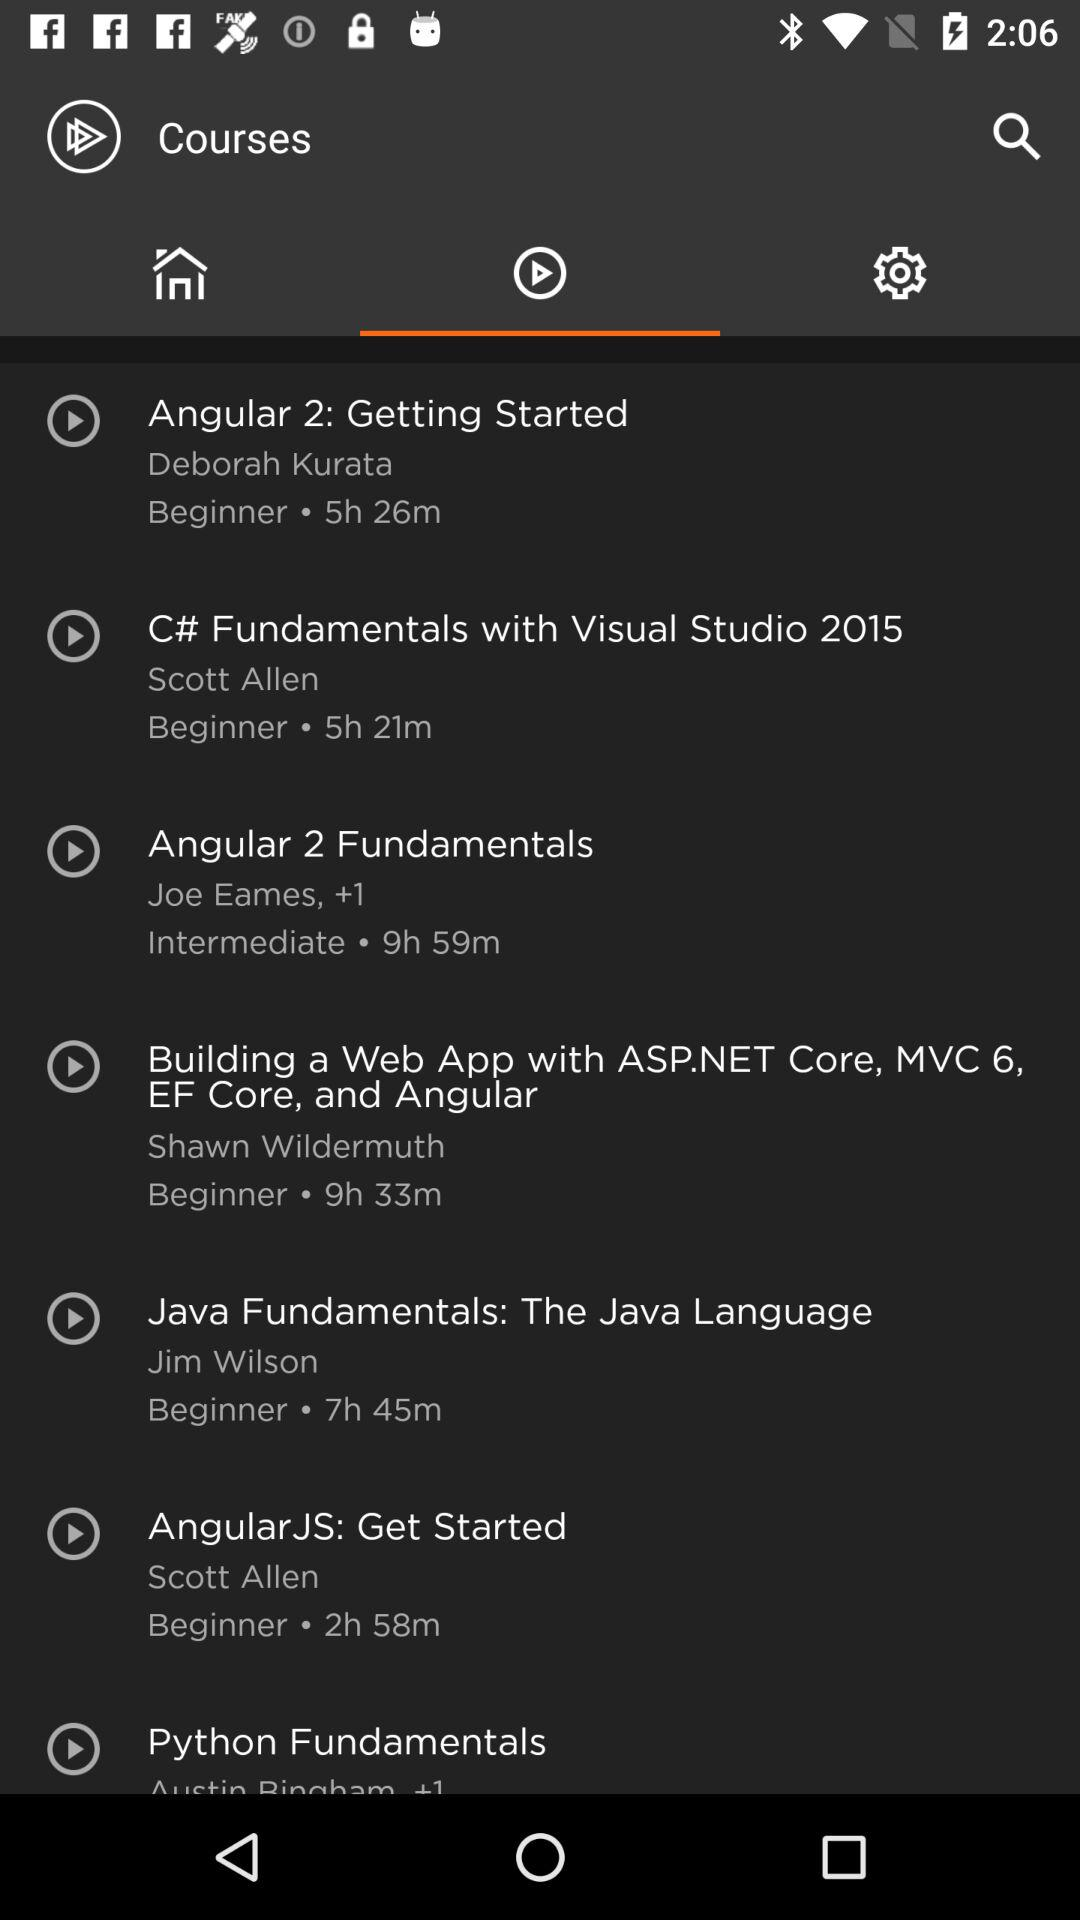Which course have maximun duration?
When the provided information is insufficient, respond with <no answer>. <no answer> 